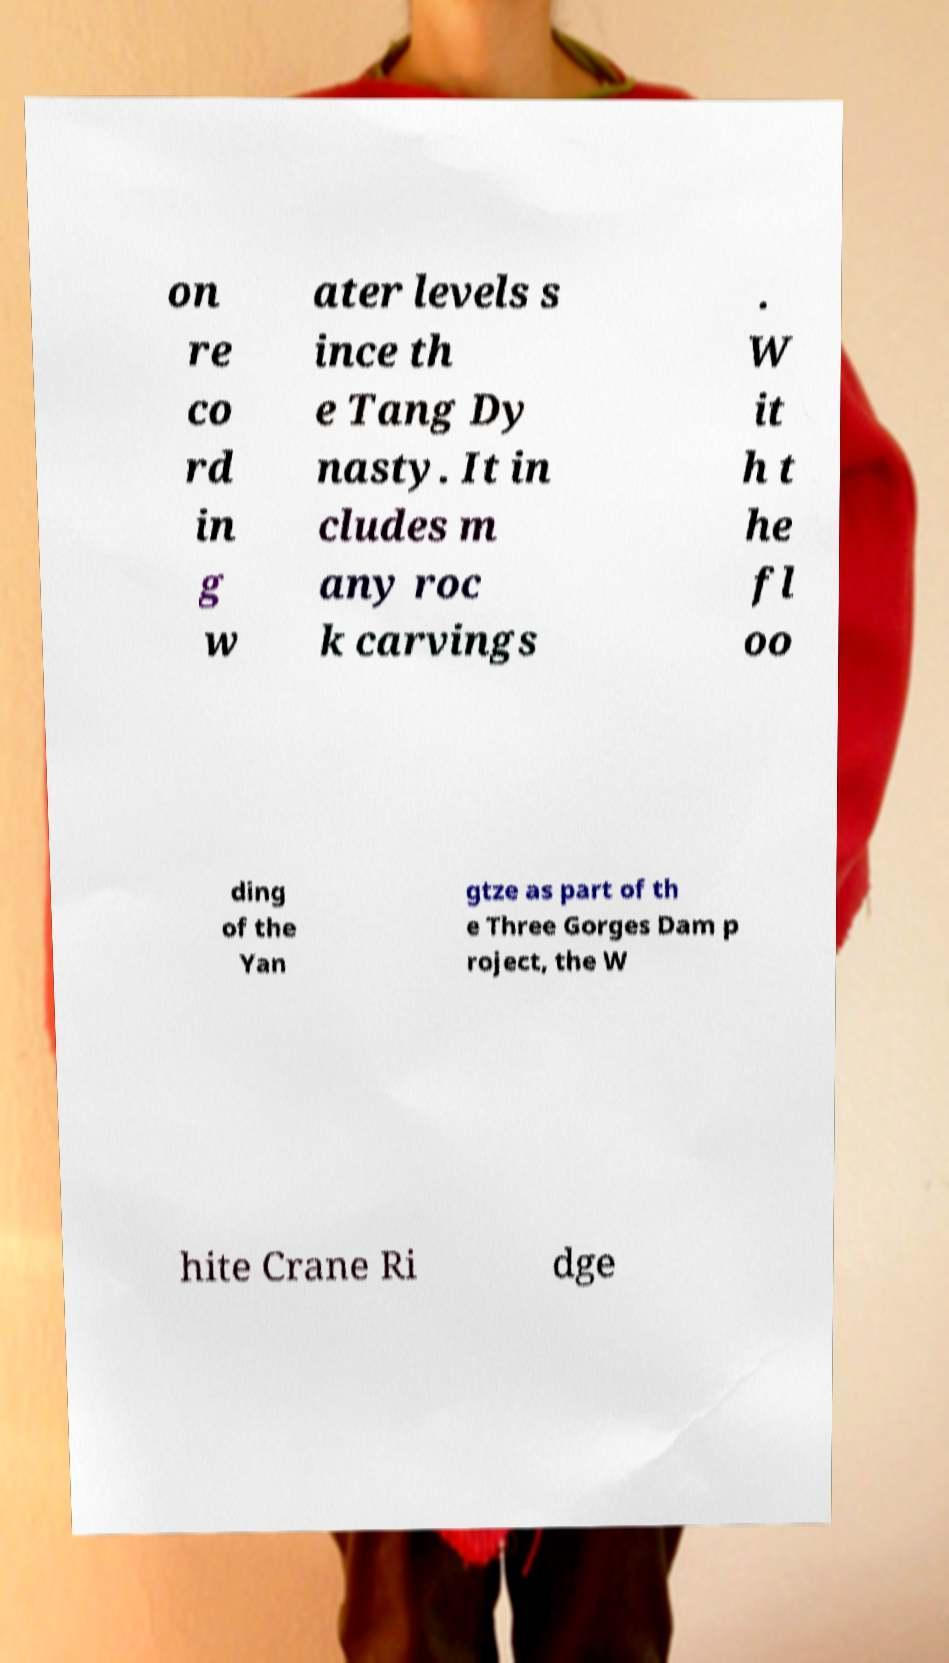Please read and relay the text visible in this image. What does it say? on re co rd in g w ater levels s ince th e Tang Dy nasty. It in cludes m any roc k carvings . W it h t he fl oo ding of the Yan gtze as part of th e Three Gorges Dam p roject, the W hite Crane Ri dge 